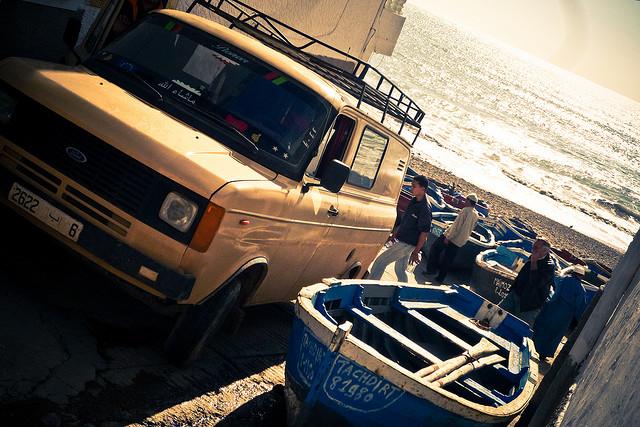Are this people going fishing?
Keep it brief. Yes. What color are the boats?
Answer briefly. Blue. What angle is the picture taken at?
Concise answer only. Angle. 